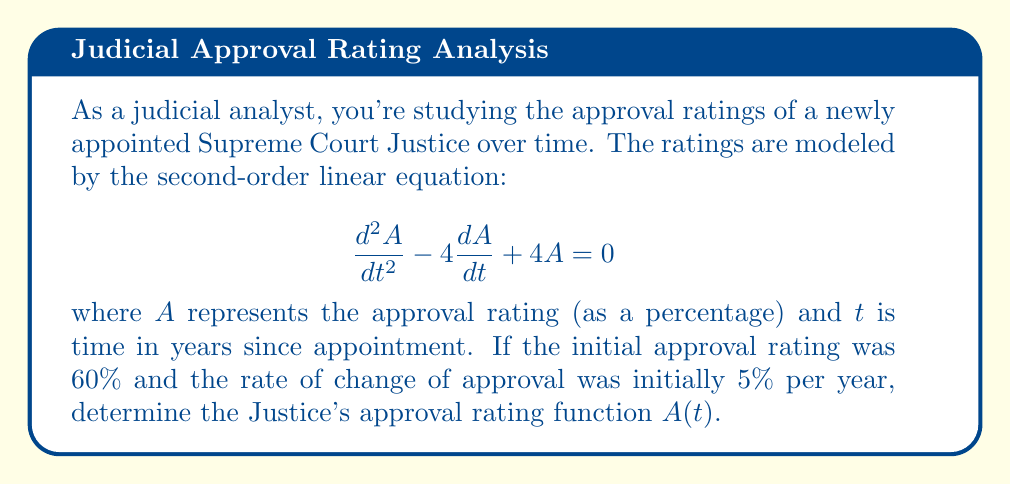Solve this math problem. Let's solve this step-by-step:

1) The characteristic equation for this second-order linear equation is:
   $$r^2 - 4r + 4 = 0$$

2) Solving this equation:
   $$(r - 2)^2 = 0$$
   $$r = 2$$ (repeated root)

3) The general solution for a repeated root is:
   $$A(t) = (c_1 + c_2t)e^{2t}$$

4) Now we use the initial conditions to find $c_1$ and $c_2$:
   
   At $t = 0$, $A(0) = 60$, so:
   $$60 = c_1$$

   For the rate of change, we differentiate $A(t)$:
   $$\frac{dA}{dt} = (c_2 + 2c_1 + 2c_2t)e^{2t}$$

   At $t = 0$, $\frac{dA}{dt} = 5$, so:
   $$5 = c_2 + 2c_1 = c_2 + 120$$
   $$c_2 = -115$$

5) Substituting these values back into our general solution:
   $$A(t) = (60 - 115t)e^{2t}$$

This is the approval rating function for the Justice over time.
Answer: $A(t) = (60 - 115t)e^{2t}$ 